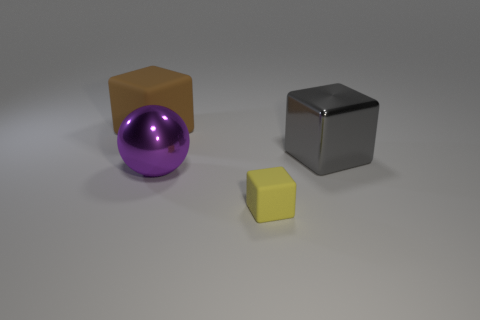Add 2 red cylinders. How many objects exist? 6 Subtract all cubes. How many objects are left? 1 Subtract all large purple shiny spheres. Subtract all tiny blocks. How many objects are left? 2 Add 1 big balls. How many big balls are left? 2 Add 1 big brown matte objects. How many big brown matte objects exist? 2 Subtract 0 blue spheres. How many objects are left? 4 